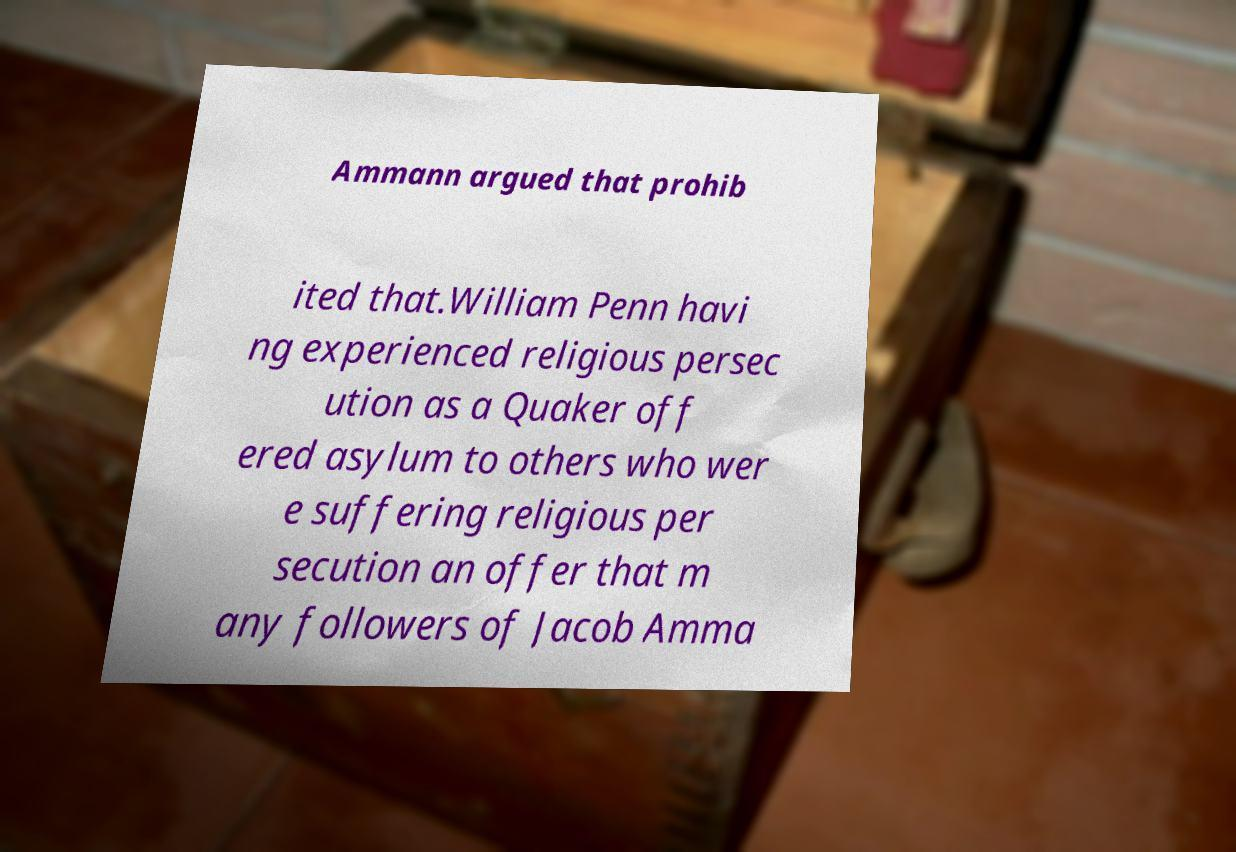For documentation purposes, I need the text within this image transcribed. Could you provide that? Ammann argued that prohib ited that.William Penn havi ng experienced religious persec ution as a Quaker off ered asylum to others who wer e suffering religious per secution an offer that m any followers of Jacob Amma 